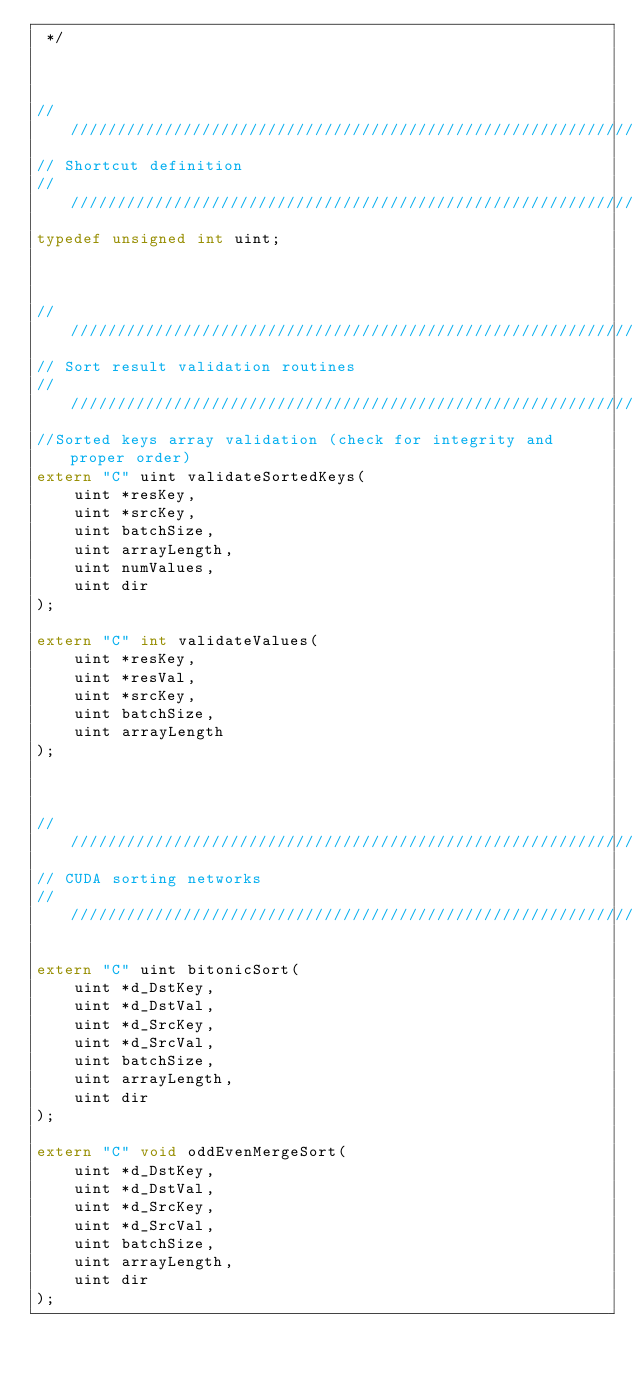<code> <loc_0><loc_0><loc_500><loc_500><_C_> */



////////////////////////////////////////////////////////////////////////////////
// Shortcut definition
////////////////////////////////////////////////////////////////////////////////
typedef unsigned int uint;



///////////////////////////////////////////////////////////////////////////////
// Sort result validation routines
////////////////////////////////////////////////////////////////////////////////
//Sorted keys array validation (check for integrity and proper order)
extern "C" uint validateSortedKeys(
    uint *resKey,
    uint *srcKey,
    uint batchSize,
    uint arrayLength,
    uint numValues,
    uint dir
);

extern "C" int validateValues(
    uint *resKey,
    uint *resVal,
    uint *srcKey,
    uint batchSize,
    uint arrayLength
);



////////////////////////////////////////////////////////////////////////////////
// CUDA sorting networks
////////////////////////////////////////////////////////////////////////////////

extern "C" uint bitonicSort(
    uint *d_DstKey,
    uint *d_DstVal,
    uint *d_SrcKey,
    uint *d_SrcVal,
    uint batchSize,
    uint arrayLength,
    uint dir
);

extern "C" void oddEvenMergeSort(
    uint *d_DstKey,
    uint *d_DstVal,
    uint *d_SrcKey,
    uint *d_SrcVal,
    uint batchSize,
    uint arrayLength,
    uint dir
);
</code> 